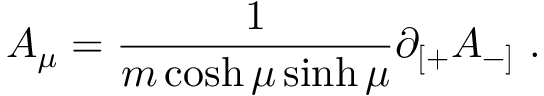<formula> <loc_0><loc_0><loc_500><loc_500>A _ { \mu } = \frac { 1 } { m \cosh \mu \sinh \mu } \partial _ { [ + } A _ { - ] } \ .</formula> 